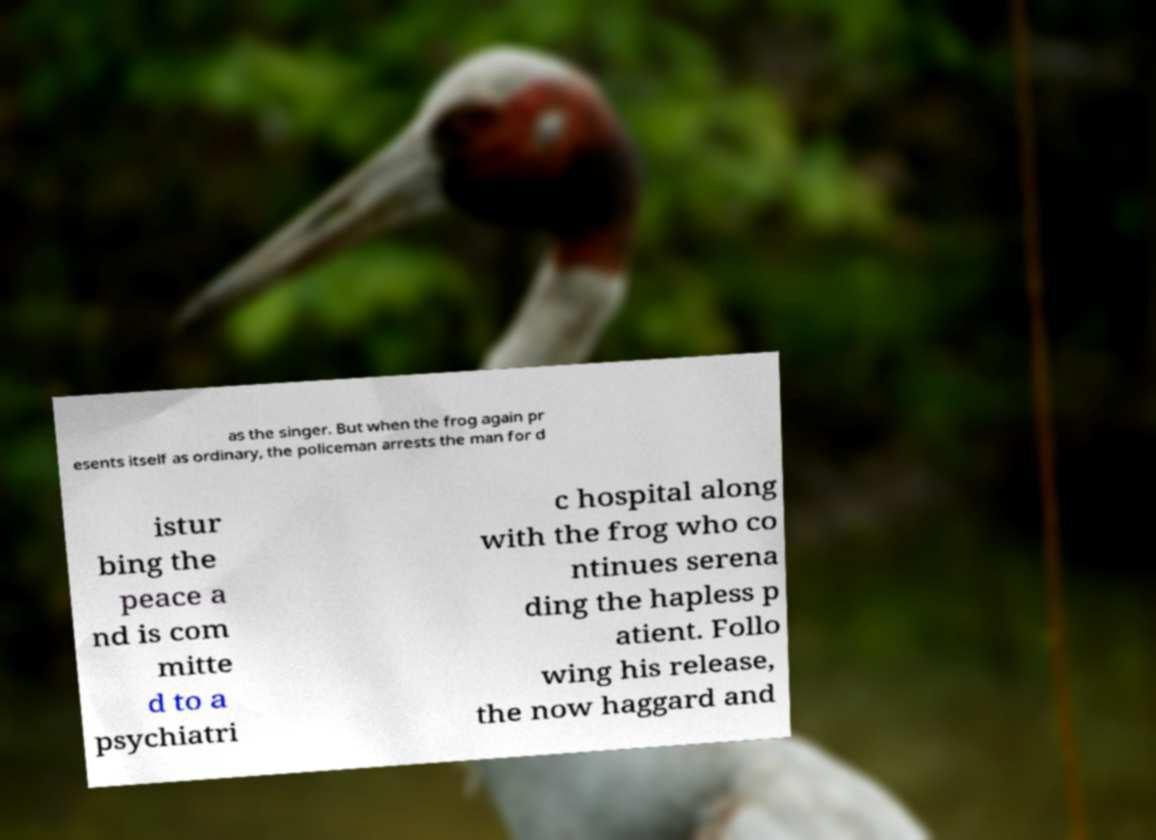Please identify and transcribe the text found in this image. as the singer. But when the frog again pr esents itself as ordinary, the policeman arrests the man for d istur bing the peace a nd is com mitte d to a psychiatri c hospital along with the frog who co ntinues serena ding the hapless p atient. Follo wing his release, the now haggard and 